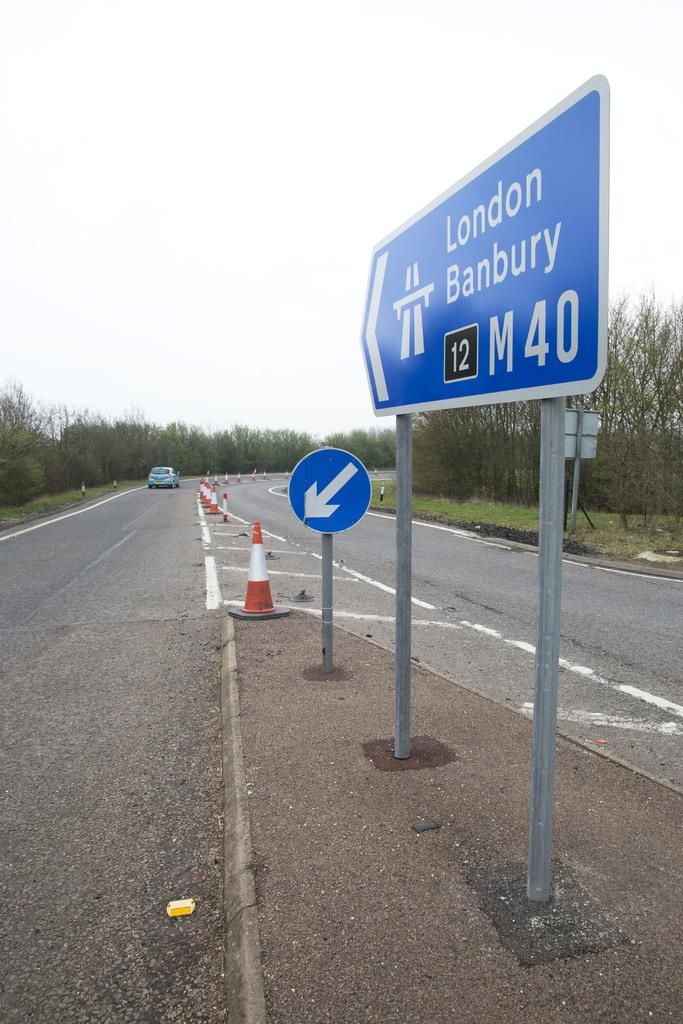<image>
Provide a brief description of the given image. A sign pointing the direction to London and Banbury. 